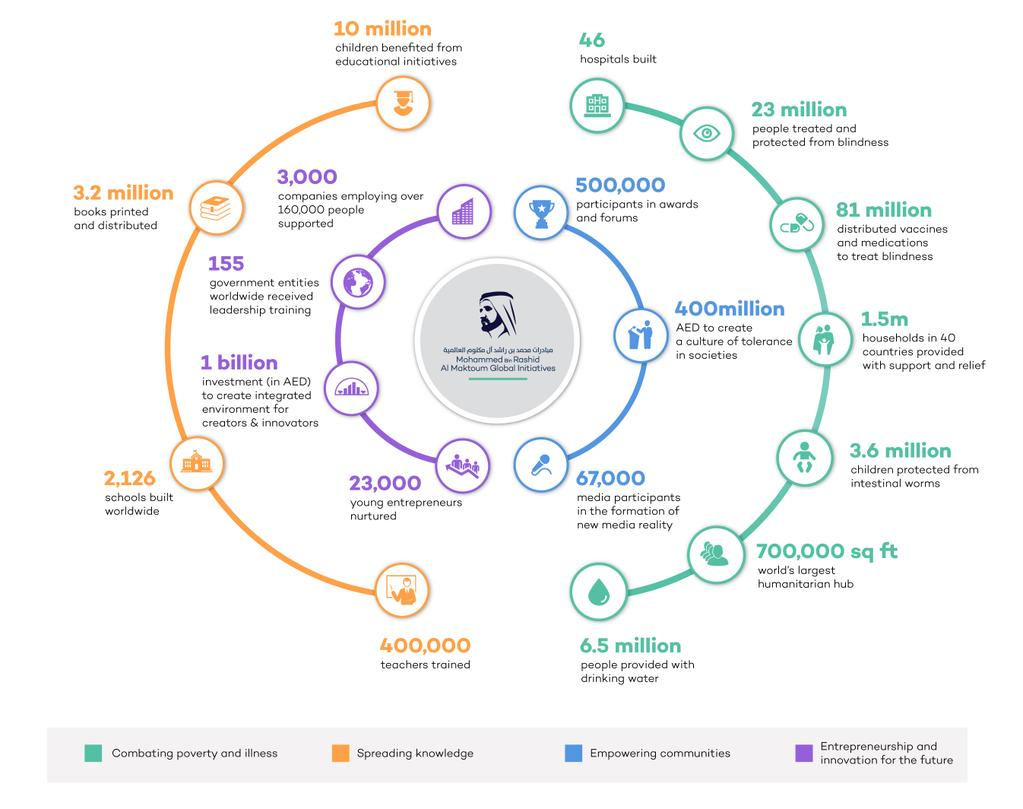Mention a couple of crucial points in this snapshot. Fifteen-five government entities worldwide have received leadership training as a part of the Mohammed bin Rashid Al Maktoum Global Initiative. The Mohammed bin Rashid Al Maktoum Global Initiatives (MBRGI) foundation has built 2,126 schools worldwide. The MBRGI foundation trained 400,000 teachers. The Mohammed bin Rashid Al Maktoum Global Initiatives (MBRGI) foundation provided drinking water to approximately 6.5 million people. As part of the Mohammed bin Rashid Al Maktoum Global Initiative, 46 hospitals were built globally. 